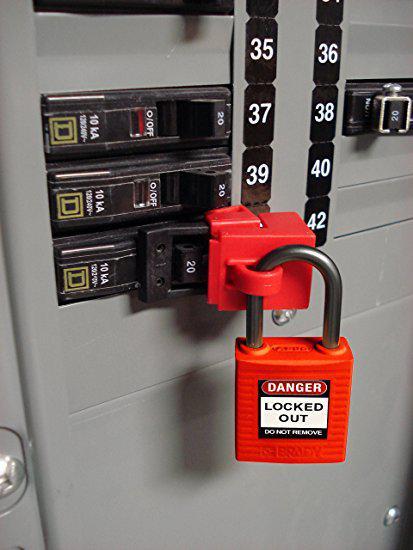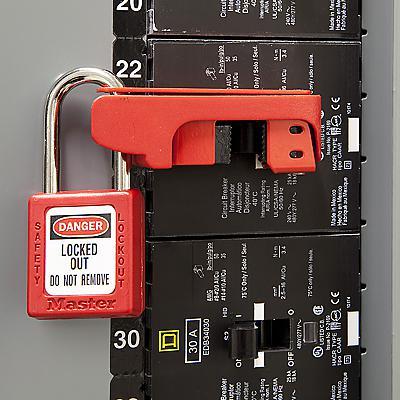The first image is the image on the left, the second image is the image on the right. Examine the images to the left and right. Is the description "Red and white stripes are visible in one of the images." accurate? Answer yes or no. No. 